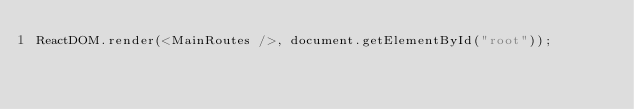Convert code to text. <code><loc_0><loc_0><loc_500><loc_500><_JavaScript_>ReactDOM.render(<MainRoutes />, document.getElementById("root"));
</code> 